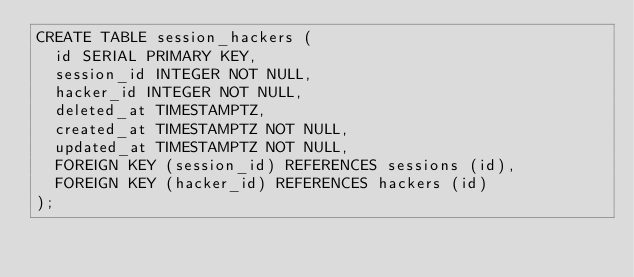<code> <loc_0><loc_0><loc_500><loc_500><_SQL_>CREATE TABLE session_hackers (
  id SERIAL PRIMARY KEY,
  session_id INTEGER NOT NULL,
  hacker_id INTEGER NOT NULL,
  deleted_at TIMESTAMPTZ,
  created_at TIMESTAMPTZ NOT NULL,
  updated_at TIMESTAMPTZ NOT NULL,
  FOREIGN KEY (session_id) REFERENCES sessions (id),
  FOREIGN KEY (hacker_id) REFERENCES hackers (id)
);
</code> 